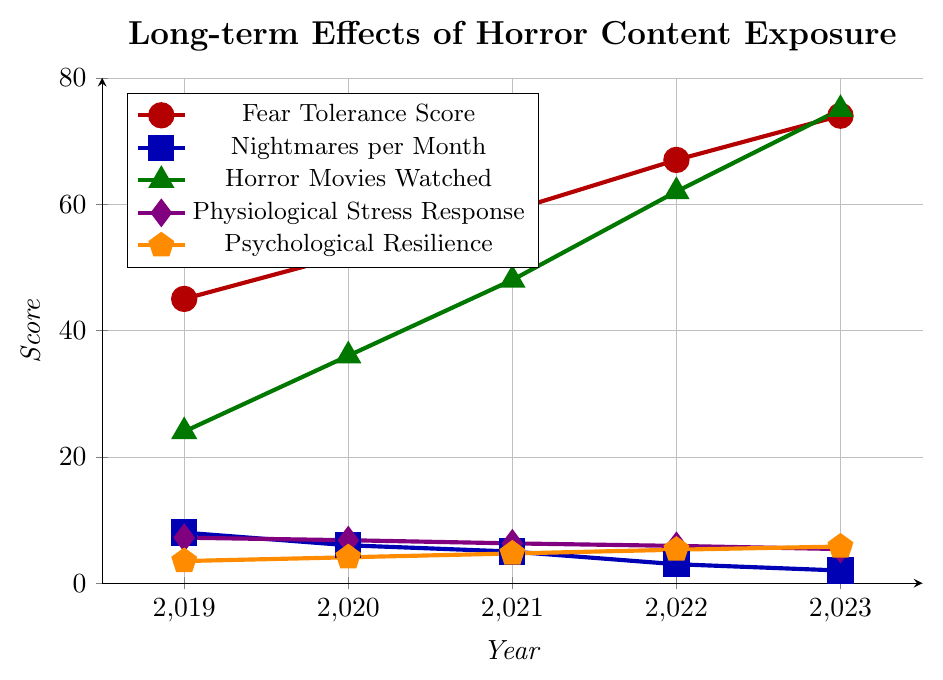Which year had the highest Fear Tolerance Score? The Fear Tolerance Score increases every year from 2019 (45) to 2023 (74). The highest value is in 2023.
Answer: 2023 What is the difference in the number of horror movies watched between 2019 and 2023? The number of horror movies watched in 2019 is 24 and in 2023 is 75. Subtracting these values, 75 - 24 = 51.
Answer: 51 How did the number of nightmares per month change from 2020 to 2023? The number of nightmares per month in 2020 is 6 and in 2023 is 2. So, the change is 6 - 2 = 4.
Answer: Decreased by 4 In which year did Psychological Resilience reach 5.3? By observing the plot, in 2022, the Psychological Resilience value is 5.3 according to the orange pentagon marks.
Answer: 2022 Compare Physicological Stress Response and Psychological Resilience in 2019. Which one is higher? In 2019, the Physiological Stress Response is 7.2 while the Psychological Resilience is 3.5. Clearly, the Physiological Stress Response is higher.
Answer: Physiological Stress Response What was the average Fear Tolerance Score over the 5-year period? Summing the Fear Tolerance Scores (45 + 52 + 59 + 67 + 74) gives 297. Dividing by 5, the average is 297 / 5 = 59.4.
Answer: 59.4 Which metric shows a decreasing trend over the years? By observing the line trends, both Nightmares per Month and Physiological Stress Response show a decreasing trend.
Answer: Nightmares per Month and Physiological Stress Response How much did the Physiological Stress Response decrease from 2019 to 2023? The Physiological Stress Response value in 2019 is 7.2 and in 2023 is 5.4. The decrease is 7.2 - 5.4 = 1.8.
Answer: 1.8 In which year did Nightmares per Month reduce to half of what it was in 2019? Nightmares per Month was 8 in 2019. Half of this value is 4. In 2021, Nightmares per Month is 5 and in 2022 it is 3, which is less than 4. Hence, it is between 2021 and 2022 when it reduced to half.
Answer: 2022 